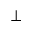Convert formula to latex. <formula><loc_0><loc_0><loc_500><loc_500>\bot</formula> 